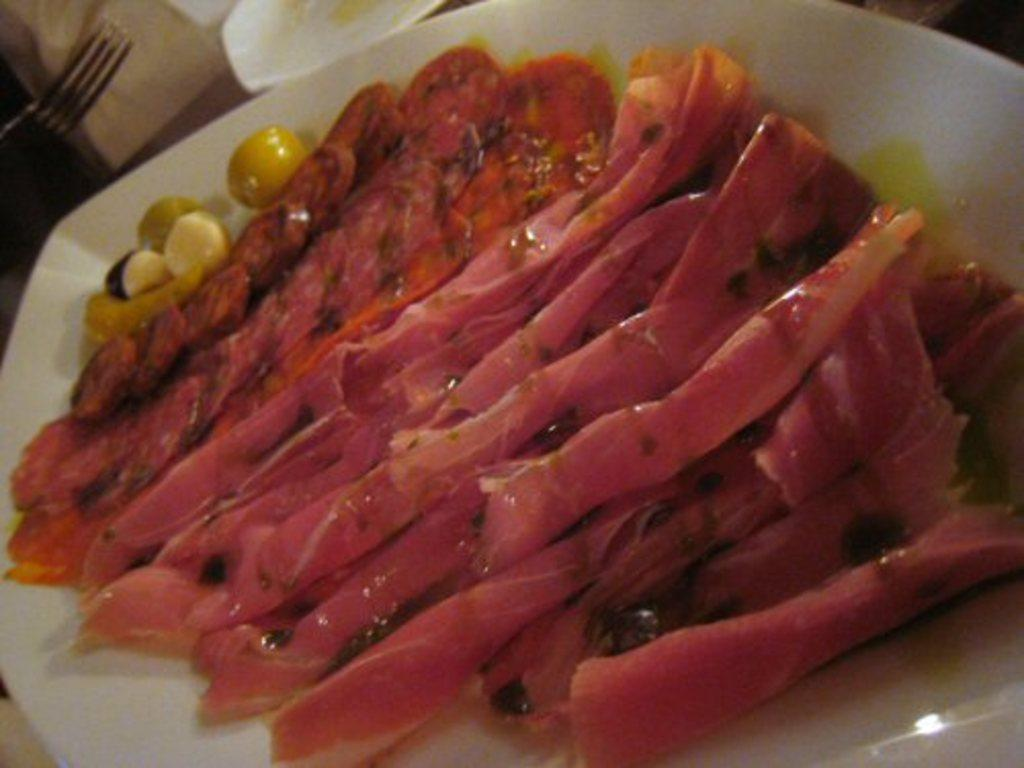What object is present in the image that might be used for serving or holding food? There is a plate in the image. What is on the plate? There is food on the plate. What utensil is located beside the plate on the left side? There is a fork beside the plate on the left side. What type of record can be seen playing on the turntable in the image? There is no turntable or record present in the image; it only features a plate with food and a fork. 